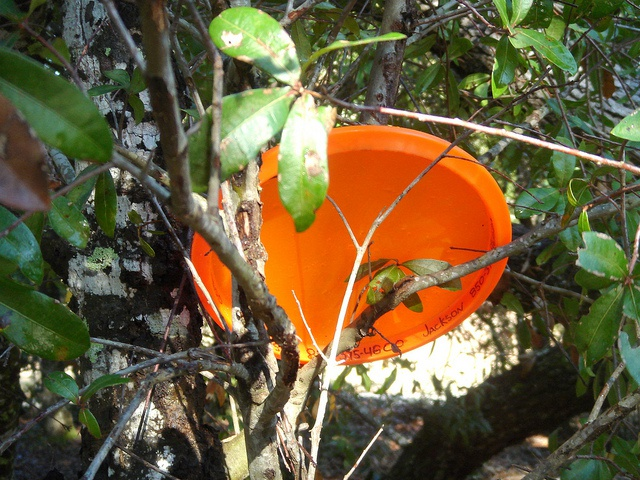Describe the objects in this image and their specific colors. I can see frisbee in darkgreen, red, orange, and maroon tones and bowl in darkgreen, red, and orange tones in this image. 